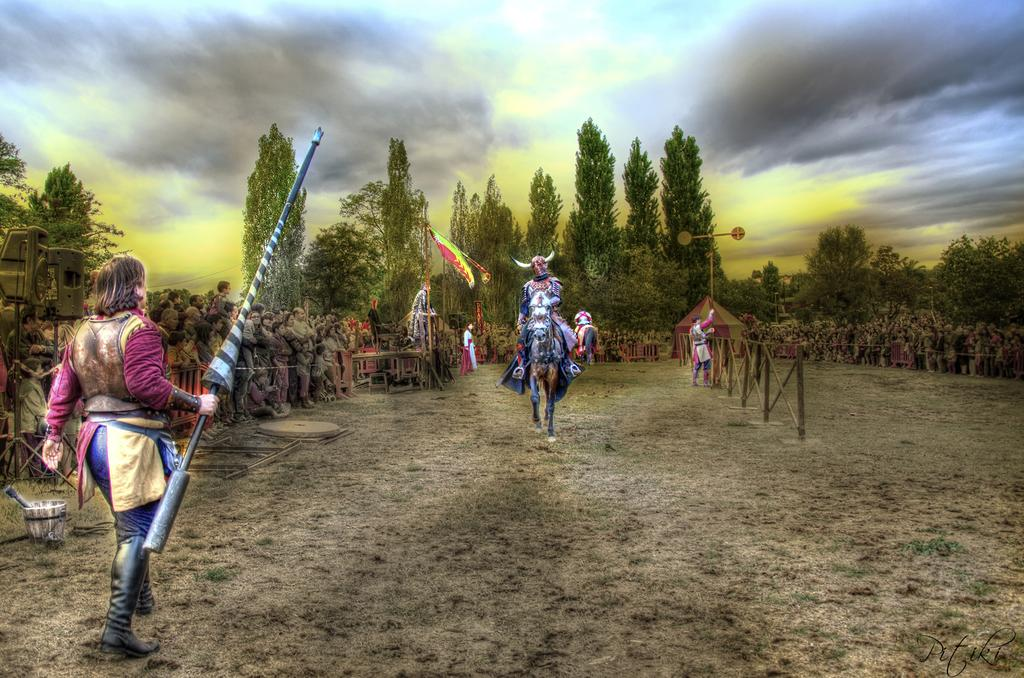What is the main subject of the image? The image contains a painting. What is being depicted in the painting? The painting depicts people and a horse. What type of terrain is shown in the painting? Grass and trees are present in the painting. What can be seen in the sky in the painting? The sky is visible in the painting, and clouds are present. What type of balls are being used by the people in the painting? There are no balls present in the painting; it depicts people, a horse, grass, trees, the sky, and clouds. 